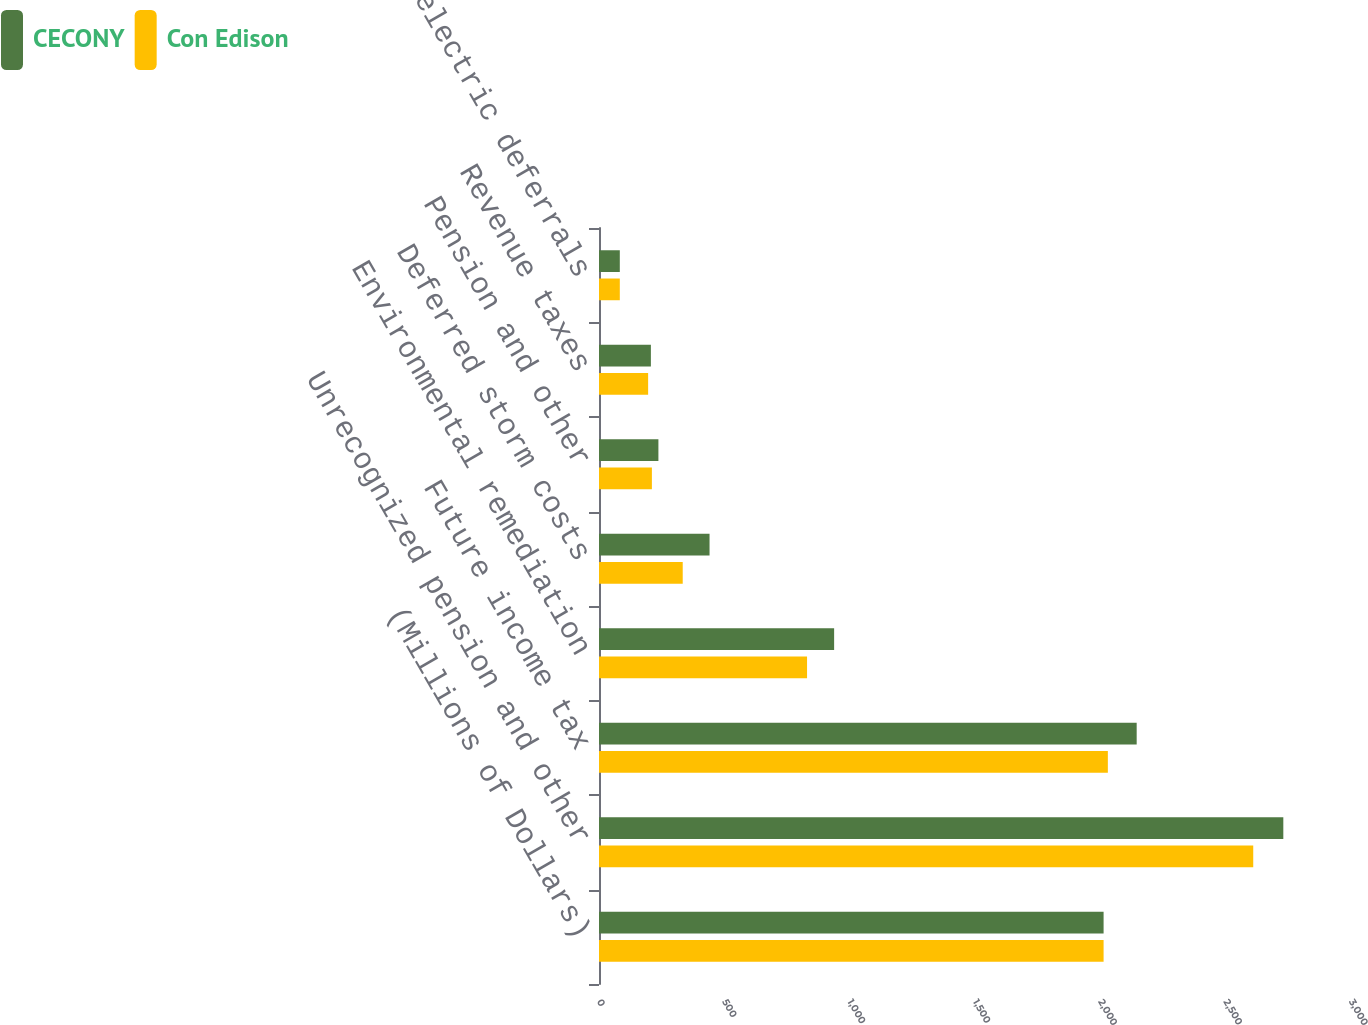Convert chart. <chart><loc_0><loc_0><loc_500><loc_500><stacked_bar_chart><ecel><fcel>(Millions of Dollars)<fcel>Unrecognized pension and other<fcel>Future income tax<fcel>Environmental remediation<fcel>Deferred storm costs<fcel>Pension and other<fcel>Revenue taxes<fcel>Net electric deferrals<nl><fcel>CECONY<fcel>2013<fcel>2730<fcel>2145<fcel>938<fcel>441<fcel>237<fcel>207<fcel>83<nl><fcel>Con Edison<fcel>2013<fcel>2610<fcel>2030<fcel>830<fcel>334<fcel>211<fcel>196<fcel>83<nl></chart> 